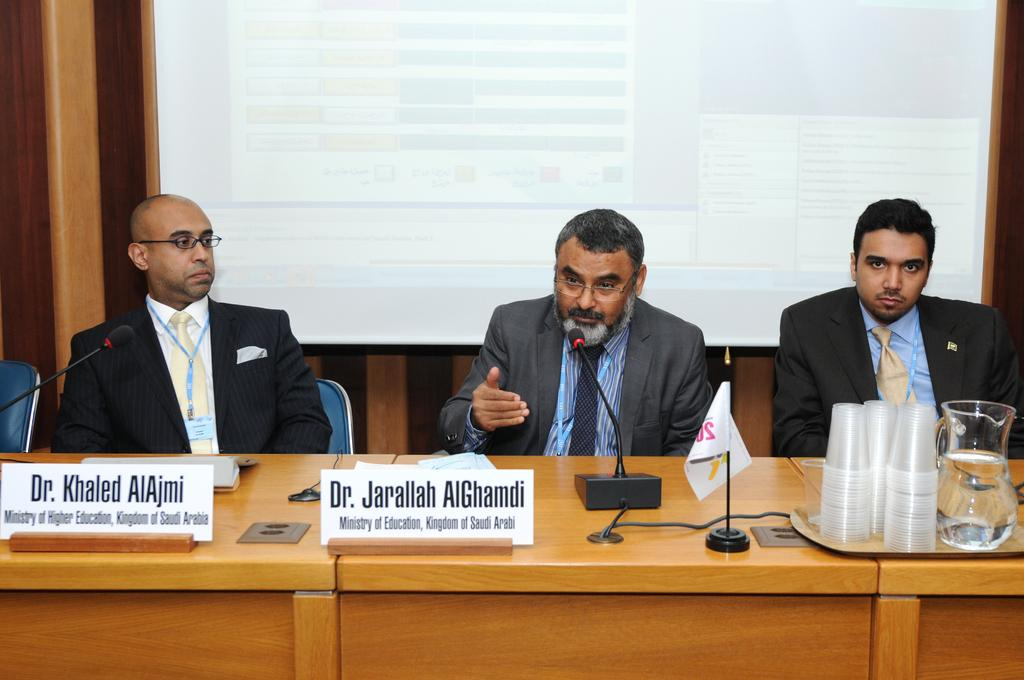How many people are sitting in the image? There are three people sitting on chairs in the image. What is present on the table in the image? A name board, microphones, a glass, a jar, and a tray are present on the table in the image. What can be seen in the background of the image? There is a screen in the background of the image. What type of grape is being used to increase the volume of the microphones in the image? There are no grapes present in the image, and grapes are not used to increase the volume of microphones. 